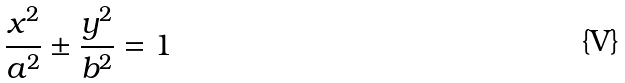<formula> <loc_0><loc_0><loc_500><loc_500>\frac { x ^ { 2 } } { a ^ { 2 } } \pm \frac { y ^ { 2 } } { b ^ { 2 } } = 1</formula> 